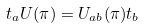<formula> <loc_0><loc_0><loc_500><loc_500>t _ { a } U ( \pi ) = U _ { a b } ( \pi ) t _ { b }</formula> 